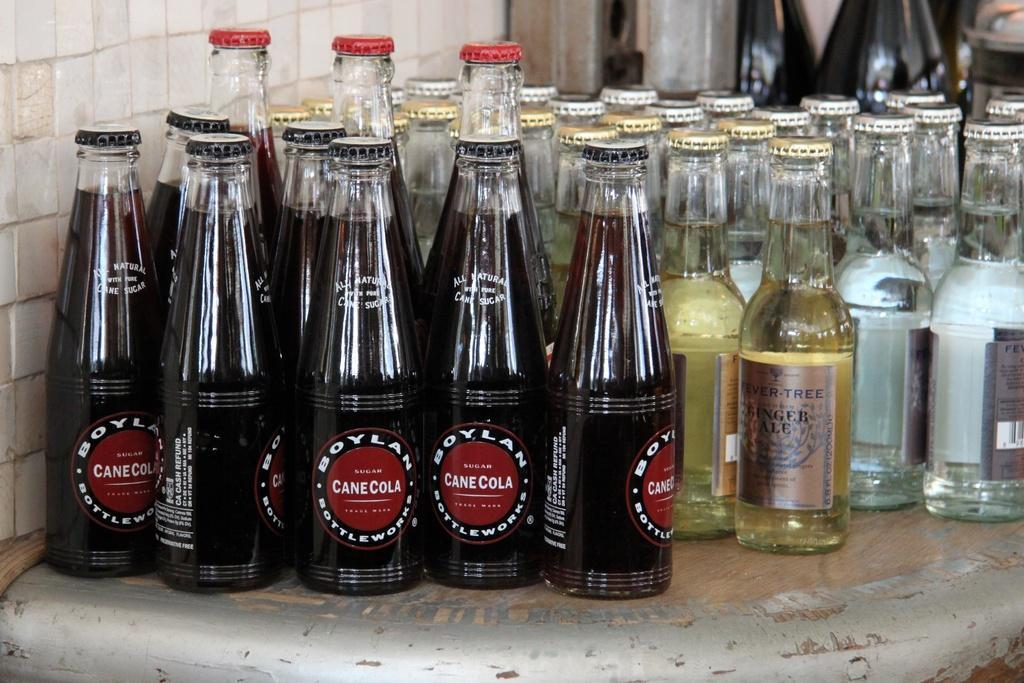Could you give a brief overview of what you see in this image? In this image I can see the glass bottles with drink. These are on the brown and ash color surface. To the left I can see the wall. 